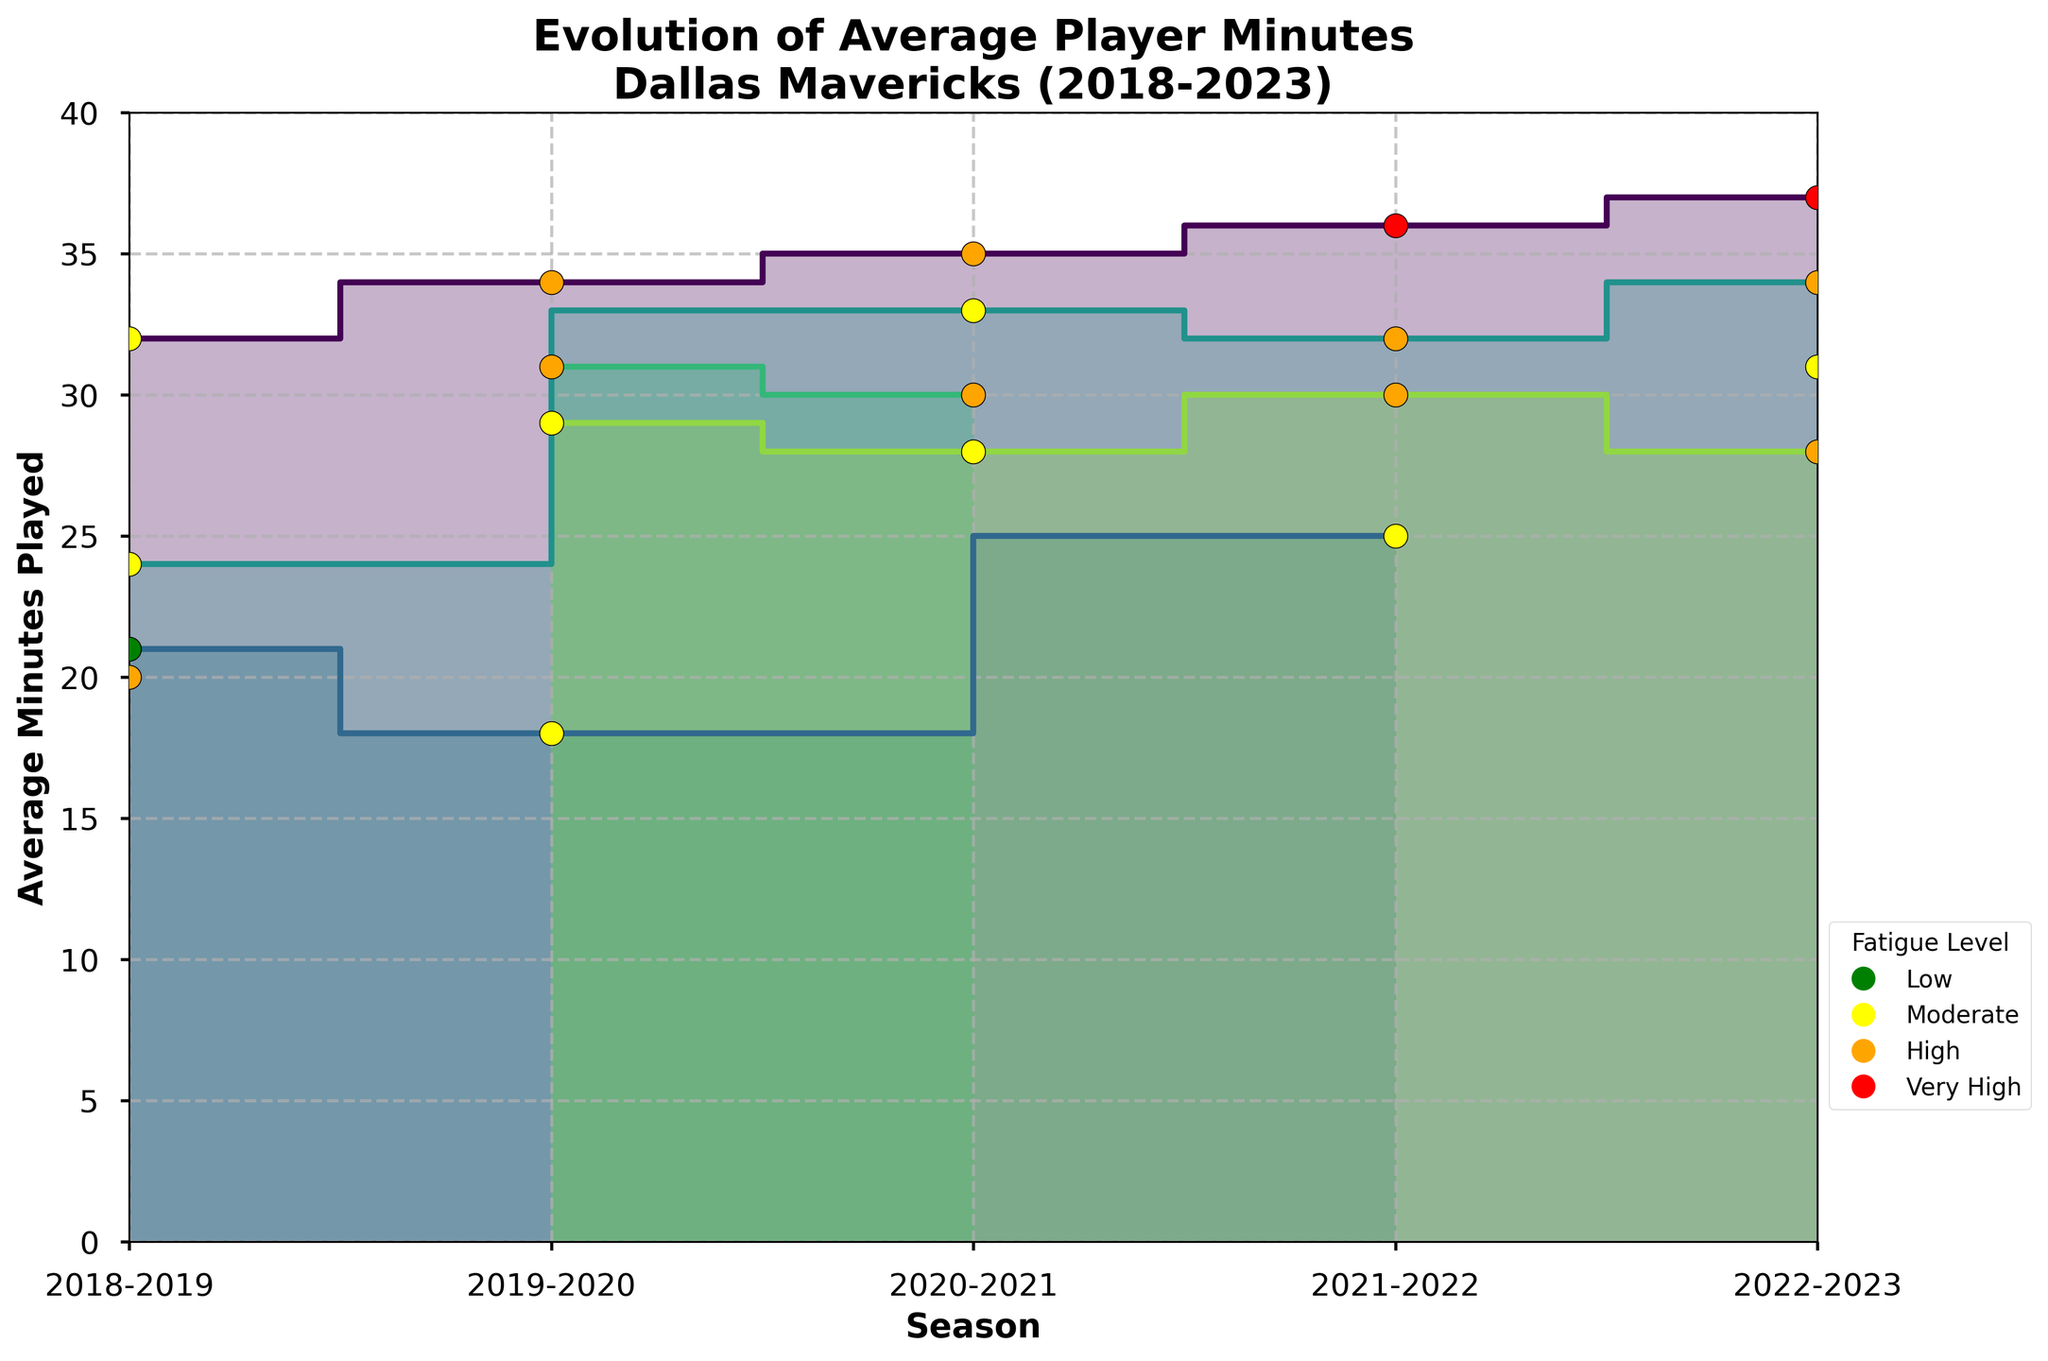what is the title of the chart? The title is clearly visible at the top of the chart. It is "Evolution of Average Player Minutes\nDallas Mavericks (2018-2023)"
Answer: Evolution of Average Player Minutes\nDallas Mavericks (2018-2023) How many players' data is shown in the chart? The chart has distinct colors for each player and labels in the legend area. Counting them gives us the total number of players.
Answer: 8 Which player had the highest average minutes played in the 2022-2023 season? We look at the step area at the rightmost end of the chart for the 2022-2023 season, and see whose line is the highest. Luka Doncic's line is the highest with 37 minutes.
Answer: Luka Doncic What color is used to represent fatigue levels in the chart? The fatigue levels are represented using colored scatter points with an edge color of black. The color legend outlines green, yellow, orange, and red for Low, Moderate, High, and Very High fatigue levels respectively.
Answer: green, yellow, orange, and red Which seasons did Luka Doncic have a 'Very High' fatigue level? By looking at the colored scatter points along Luka Doncic's step line and matching it to the legend, the points for 'Very High' (red) are in the 2021-2022 and 2022-2023 seasons.
Answer: 2021-2022, 2022-2023 Compare the average minutes of Luka Doncic and Tim Hardaway Jr. in the 2021-2022 season. Who played more minutes and by how much? In the 2021-2022 season, Luka Doncic had an average of 36 minutes and Tim Hardaway Jr. had 30 minutes. Therefore, Luka Doncic played more. 36 - 30 = 6 minutes more.
Answer: Luka Doncic, 6 minutes What is the general trend in average minutes for Luka Doncic over the seasons? Luka Doncic's average minutes consistently increase every season from 32 in 2018-2019 to 37 in 2022-2023.
Answer: Increasing Between 2019-2020 and 2020-2021, did Kristaps Porzingis play more or fewer average minutes? Checking the height of the steps between these seasons for Kristaps Porzingis, he played 31 minutes in 2019-2020 and 30 minutes in 2020-2021. Therefore, he played fewer minutes in 2020-2021.
Answer: Fewer Are there any players who showed consistent 'High' or 'Very High' fatigue levels across all recorded seasons? The scatter points for fatigue are color-coded, and we need to look for either sustained red (Very High) or orange (High) points for any player across all seasons. Luka Doncic consistently shows 'High' or 'Very High' fatigue from 2019-2023, and Tim Hardaway Jr. shows 'High' rather consistently in his recorded seasons.
Answer: Luka Doncic What was the reported fatigue level of Tim Hardaway Jr. in the 2019-2020 season? By looking at the scatter points along Tim Hardaway Jr.'s step area in the 2019-2020 season, his point is yellow, which corresponds to 'Moderate' fatigue level from the legend.
Answer: Moderate 